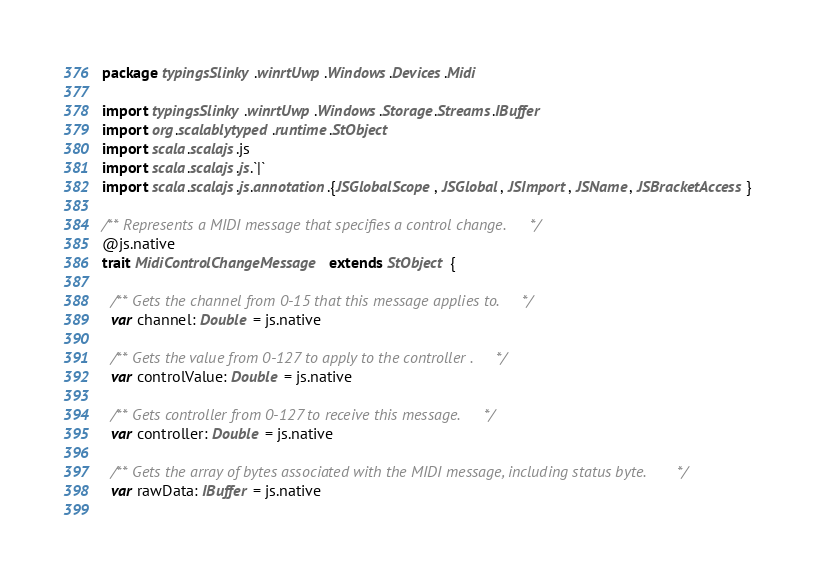Convert code to text. <code><loc_0><loc_0><loc_500><loc_500><_Scala_>package typingsSlinky.winrtUwp.Windows.Devices.Midi

import typingsSlinky.winrtUwp.Windows.Storage.Streams.IBuffer
import org.scalablytyped.runtime.StObject
import scala.scalajs.js
import scala.scalajs.js.`|`
import scala.scalajs.js.annotation.{JSGlobalScope, JSGlobal, JSImport, JSName, JSBracketAccess}

/** Represents a MIDI message that specifies a control change. */
@js.native
trait MidiControlChangeMessage extends StObject {
  
  /** Gets the channel from 0-15 that this message applies to. */
  var channel: Double = js.native
  
  /** Gets the value from 0-127 to apply to the controller . */
  var controlValue: Double = js.native
  
  /** Gets controller from 0-127 to receive this message. */
  var controller: Double = js.native
  
  /** Gets the array of bytes associated with the MIDI message, including status byte. */
  var rawData: IBuffer = js.native
  </code> 